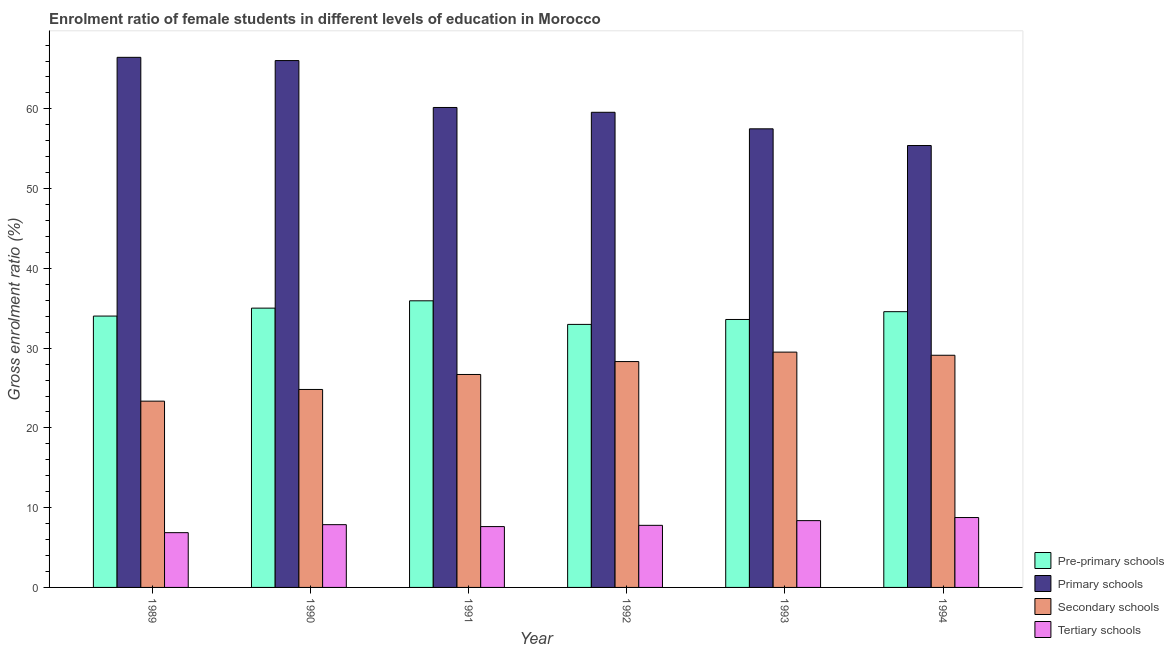How many groups of bars are there?
Keep it short and to the point. 6. In how many cases, is the number of bars for a given year not equal to the number of legend labels?
Give a very brief answer. 0. What is the gross enrolment ratio(male) in pre-primary schools in 1991?
Make the answer very short. 35.94. Across all years, what is the maximum gross enrolment ratio(male) in tertiary schools?
Offer a terse response. 8.76. Across all years, what is the minimum gross enrolment ratio(male) in pre-primary schools?
Your response must be concise. 32.98. In which year was the gross enrolment ratio(male) in primary schools maximum?
Provide a short and direct response. 1989. What is the total gross enrolment ratio(male) in secondary schools in the graph?
Your answer should be compact. 161.81. What is the difference between the gross enrolment ratio(male) in primary schools in 1989 and that in 1993?
Keep it short and to the point. 8.96. What is the difference between the gross enrolment ratio(male) in primary schools in 1993 and the gross enrolment ratio(male) in pre-primary schools in 1991?
Your response must be concise. -2.68. What is the average gross enrolment ratio(male) in pre-primary schools per year?
Your response must be concise. 34.36. In how many years, is the gross enrolment ratio(male) in primary schools greater than 42 %?
Ensure brevity in your answer.  6. What is the ratio of the gross enrolment ratio(male) in primary schools in 1989 to that in 1990?
Your response must be concise. 1.01. Is the gross enrolment ratio(male) in secondary schools in 1991 less than that in 1994?
Make the answer very short. Yes. Is the difference between the gross enrolment ratio(male) in primary schools in 1991 and 1994 greater than the difference between the gross enrolment ratio(male) in pre-primary schools in 1991 and 1994?
Keep it short and to the point. No. What is the difference between the highest and the second highest gross enrolment ratio(male) in tertiary schools?
Your answer should be compact. 0.39. What is the difference between the highest and the lowest gross enrolment ratio(male) in tertiary schools?
Your answer should be very brief. 1.9. Is the sum of the gross enrolment ratio(male) in tertiary schools in 1992 and 1994 greater than the maximum gross enrolment ratio(male) in primary schools across all years?
Offer a very short reply. Yes. Is it the case that in every year, the sum of the gross enrolment ratio(male) in secondary schools and gross enrolment ratio(male) in tertiary schools is greater than the sum of gross enrolment ratio(male) in pre-primary schools and gross enrolment ratio(male) in primary schools?
Offer a terse response. No. What does the 4th bar from the left in 1993 represents?
Make the answer very short. Tertiary schools. What does the 3rd bar from the right in 1994 represents?
Offer a very short reply. Primary schools. How many bars are there?
Ensure brevity in your answer.  24. How many years are there in the graph?
Give a very brief answer. 6. What is the difference between two consecutive major ticks on the Y-axis?
Your answer should be very brief. 10. Are the values on the major ticks of Y-axis written in scientific E-notation?
Ensure brevity in your answer.  No. How many legend labels are there?
Provide a succinct answer. 4. What is the title of the graph?
Your answer should be compact. Enrolment ratio of female students in different levels of education in Morocco. What is the Gross enrolment ratio (%) in Pre-primary schools in 1989?
Offer a terse response. 34.02. What is the Gross enrolment ratio (%) of Primary schools in 1989?
Keep it short and to the point. 66.47. What is the Gross enrolment ratio (%) in Secondary schools in 1989?
Make the answer very short. 23.36. What is the Gross enrolment ratio (%) of Tertiary schools in 1989?
Your response must be concise. 6.87. What is the Gross enrolment ratio (%) of Pre-primary schools in 1990?
Offer a terse response. 35.02. What is the Gross enrolment ratio (%) in Primary schools in 1990?
Ensure brevity in your answer.  66.06. What is the Gross enrolment ratio (%) of Secondary schools in 1990?
Ensure brevity in your answer.  24.82. What is the Gross enrolment ratio (%) in Tertiary schools in 1990?
Offer a terse response. 7.87. What is the Gross enrolment ratio (%) in Pre-primary schools in 1991?
Keep it short and to the point. 35.94. What is the Gross enrolment ratio (%) of Primary schools in 1991?
Ensure brevity in your answer.  60.18. What is the Gross enrolment ratio (%) of Secondary schools in 1991?
Your answer should be compact. 26.7. What is the Gross enrolment ratio (%) in Tertiary schools in 1991?
Make the answer very short. 7.63. What is the Gross enrolment ratio (%) of Pre-primary schools in 1992?
Provide a succinct answer. 32.98. What is the Gross enrolment ratio (%) of Primary schools in 1992?
Keep it short and to the point. 59.57. What is the Gross enrolment ratio (%) in Secondary schools in 1992?
Provide a short and direct response. 28.32. What is the Gross enrolment ratio (%) of Tertiary schools in 1992?
Your response must be concise. 7.79. What is the Gross enrolment ratio (%) of Pre-primary schools in 1993?
Give a very brief answer. 33.6. What is the Gross enrolment ratio (%) in Primary schools in 1993?
Offer a terse response. 57.5. What is the Gross enrolment ratio (%) in Secondary schools in 1993?
Give a very brief answer. 29.5. What is the Gross enrolment ratio (%) in Tertiary schools in 1993?
Your answer should be very brief. 8.38. What is the Gross enrolment ratio (%) in Pre-primary schools in 1994?
Your answer should be very brief. 34.57. What is the Gross enrolment ratio (%) of Primary schools in 1994?
Provide a succinct answer. 55.41. What is the Gross enrolment ratio (%) of Secondary schools in 1994?
Offer a very short reply. 29.11. What is the Gross enrolment ratio (%) of Tertiary schools in 1994?
Your answer should be very brief. 8.76. Across all years, what is the maximum Gross enrolment ratio (%) in Pre-primary schools?
Offer a very short reply. 35.94. Across all years, what is the maximum Gross enrolment ratio (%) in Primary schools?
Ensure brevity in your answer.  66.47. Across all years, what is the maximum Gross enrolment ratio (%) of Secondary schools?
Your answer should be very brief. 29.5. Across all years, what is the maximum Gross enrolment ratio (%) of Tertiary schools?
Provide a short and direct response. 8.76. Across all years, what is the minimum Gross enrolment ratio (%) of Pre-primary schools?
Make the answer very short. 32.98. Across all years, what is the minimum Gross enrolment ratio (%) of Primary schools?
Offer a terse response. 55.41. Across all years, what is the minimum Gross enrolment ratio (%) of Secondary schools?
Offer a very short reply. 23.36. Across all years, what is the minimum Gross enrolment ratio (%) of Tertiary schools?
Keep it short and to the point. 6.87. What is the total Gross enrolment ratio (%) in Pre-primary schools in the graph?
Provide a succinct answer. 206.13. What is the total Gross enrolment ratio (%) of Primary schools in the graph?
Offer a terse response. 365.18. What is the total Gross enrolment ratio (%) of Secondary schools in the graph?
Offer a very short reply. 161.81. What is the total Gross enrolment ratio (%) in Tertiary schools in the graph?
Give a very brief answer. 47.29. What is the difference between the Gross enrolment ratio (%) of Pre-primary schools in 1989 and that in 1990?
Provide a succinct answer. -1. What is the difference between the Gross enrolment ratio (%) in Primary schools in 1989 and that in 1990?
Keep it short and to the point. 0.41. What is the difference between the Gross enrolment ratio (%) of Secondary schools in 1989 and that in 1990?
Offer a very short reply. -1.46. What is the difference between the Gross enrolment ratio (%) in Tertiary schools in 1989 and that in 1990?
Provide a short and direct response. -1. What is the difference between the Gross enrolment ratio (%) in Pre-primary schools in 1989 and that in 1991?
Offer a terse response. -1.92. What is the difference between the Gross enrolment ratio (%) of Primary schools in 1989 and that in 1991?
Provide a short and direct response. 6.29. What is the difference between the Gross enrolment ratio (%) of Secondary schools in 1989 and that in 1991?
Your response must be concise. -3.34. What is the difference between the Gross enrolment ratio (%) in Tertiary schools in 1989 and that in 1991?
Your answer should be compact. -0.76. What is the difference between the Gross enrolment ratio (%) in Pre-primary schools in 1989 and that in 1992?
Keep it short and to the point. 1.04. What is the difference between the Gross enrolment ratio (%) of Primary schools in 1989 and that in 1992?
Your answer should be very brief. 6.89. What is the difference between the Gross enrolment ratio (%) in Secondary schools in 1989 and that in 1992?
Provide a succinct answer. -4.96. What is the difference between the Gross enrolment ratio (%) of Tertiary schools in 1989 and that in 1992?
Your response must be concise. -0.92. What is the difference between the Gross enrolment ratio (%) in Pre-primary schools in 1989 and that in 1993?
Make the answer very short. 0.43. What is the difference between the Gross enrolment ratio (%) of Primary schools in 1989 and that in 1993?
Your response must be concise. 8.96. What is the difference between the Gross enrolment ratio (%) in Secondary schools in 1989 and that in 1993?
Keep it short and to the point. -6.15. What is the difference between the Gross enrolment ratio (%) in Tertiary schools in 1989 and that in 1993?
Your answer should be compact. -1.51. What is the difference between the Gross enrolment ratio (%) of Pre-primary schools in 1989 and that in 1994?
Offer a terse response. -0.55. What is the difference between the Gross enrolment ratio (%) in Primary schools in 1989 and that in 1994?
Make the answer very short. 11.06. What is the difference between the Gross enrolment ratio (%) in Secondary schools in 1989 and that in 1994?
Offer a very short reply. -5.75. What is the difference between the Gross enrolment ratio (%) in Tertiary schools in 1989 and that in 1994?
Offer a terse response. -1.9. What is the difference between the Gross enrolment ratio (%) in Pre-primary schools in 1990 and that in 1991?
Keep it short and to the point. -0.92. What is the difference between the Gross enrolment ratio (%) in Primary schools in 1990 and that in 1991?
Your answer should be very brief. 5.88. What is the difference between the Gross enrolment ratio (%) of Secondary schools in 1990 and that in 1991?
Make the answer very short. -1.88. What is the difference between the Gross enrolment ratio (%) of Tertiary schools in 1990 and that in 1991?
Your answer should be compact. 0.24. What is the difference between the Gross enrolment ratio (%) of Pre-primary schools in 1990 and that in 1992?
Your answer should be very brief. 2.04. What is the difference between the Gross enrolment ratio (%) in Primary schools in 1990 and that in 1992?
Your response must be concise. 6.49. What is the difference between the Gross enrolment ratio (%) of Secondary schools in 1990 and that in 1992?
Ensure brevity in your answer.  -3.5. What is the difference between the Gross enrolment ratio (%) in Tertiary schools in 1990 and that in 1992?
Your answer should be compact. 0.08. What is the difference between the Gross enrolment ratio (%) in Pre-primary schools in 1990 and that in 1993?
Your answer should be compact. 1.42. What is the difference between the Gross enrolment ratio (%) in Primary schools in 1990 and that in 1993?
Provide a short and direct response. 8.56. What is the difference between the Gross enrolment ratio (%) of Secondary schools in 1990 and that in 1993?
Your answer should be compact. -4.68. What is the difference between the Gross enrolment ratio (%) in Tertiary schools in 1990 and that in 1993?
Give a very brief answer. -0.51. What is the difference between the Gross enrolment ratio (%) in Pre-primary schools in 1990 and that in 1994?
Offer a very short reply. 0.44. What is the difference between the Gross enrolment ratio (%) in Primary schools in 1990 and that in 1994?
Your answer should be compact. 10.65. What is the difference between the Gross enrolment ratio (%) of Secondary schools in 1990 and that in 1994?
Provide a short and direct response. -4.29. What is the difference between the Gross enrolment ratio (%) of Tertiary schools in 1990 and that in 1994?
Provide a succinct answer. -0.89. What is the difference between the Gross enrolment ratio (%) in Pre-primary schools in 1991 and that in 1992?
Offer a very short reply. 2.96. What is the difference between the Gross enrolment ratio (%) in Primary schools in 1991 and that in 1992?
Make the answer very short. 0.6. What is the difference between the Gross enrolment ratio (%) in Secondary schools in 1991 and that in 1992?
Offer a terse response. -1.62. What is the difference between the Gross enrolment ratio (%) in Tertiary schools in 1991 and that in 1992?
Ensure brevity in your answer.  -0.16. What is the difference between the Gross enrolment ratio (%) of Pre-primary schools in 1991 and that in 1993?
Provide a short and direct response. 2.34. What is the difference between the Gross enrolment ratio (%) of Primary schools in 1991 and that in 1993?
Offer a very short reply. 2.68. What is the difference between the Gross enrolment ratio (%) in Secondary schools in 1991 and that in 1993?
Offer a terse response. -2.8. What is the difference between the Gross enrolment ratio (%) in Tertiary schools in 1991 and that in 1993?
Offer a very short reply. -0.75. What is the difference between the Gross enrolment ratio (%) in Pre-primary schools in 1991 and that in 1994?
Provide a succinct answer. 1.36. What is the difference between the Gross enrolment ratio (%) in Primary schools in 1991 and that in 1994?
Your response must be concise. 4.77. What is the difference between the Gross enrolment ratio (%) in Secondary schools in 1991 and that in 1994?
Offer a terse response. -2.41. What is the difference between the Gross enrolment ratio (%) of Tertiary schools in 1991 and that in 1994?
Your answer should be very brief. -1.13. What is the difference between the Gross enrolment ratio (%) in Pre-primary schools in 1992 and that in 1993?
Give a very brief answer. -0.62. What is the difference between the Gross enrolment ratio (%) in Primary schools in 1992 and that in 1993?
Provide a short and direct response. 2.07. What is the difference between the Gross enrolment ratio (%) of Secondary schools in 1992 and that in 1993?
Provide a succinct answer. -1.19. What is the difference between the Gross enrolment ratio (%) of Tertiary schools in 1992 and that in 1993?
Offer a terse response. -0.59. What is the difference between the Gross enrolment ratio (%) in Pre-primary schools in 1992 and that in 1994?
Ensure brevity in your answer.  -1.59. What is the difference between the Gross enrolment ratio (%) in Primary schools in 1992 and that in 1994?
Your answer should be compact. 4.17. What is the difference between the Gross enrolment ratio (%) in Secondary schools in 1992 and that in 1994?
Make the answer very short. -0.79. What is the difference between the Gross enrolment ratio (%) of Tertiary schools in 1992 and that in 1994?
Your answer should be compact. -0.98. What is the difference between the Gross enrolment ratio (%) in Pre-primary schools in 1993 and that in 1994?
Keep it short and to the point. -0.98. What is the difference between the Gross enrolment ratio (%) in Primary schools in 1993 and that in 1994?
Provide a short and direct response. 2.09. What is the difference between the Gross enrolment ratio (%) of Secondary schools in 1993 and that in 1994?
Provide a succinct answer. 0.4. What is the difference between the Gross enrolment ratio (%) of Tertiary schools in 1993 and that in 1994?
Your response must be concise. -0.39. What is the difference between the Gross enrolment ratio (%) of Pre-primary schools in 1989 and the Gross enrolment ratio (%) of Primary schools in 1990?
Provide a succinct answer. -32.04. What is the difference between the Gross enrolment ratio (%) in Pre-primary schools in 1989 and the Gross enrolment ratio (%) in Secondary schools in 1990?
Keep it short and to the point. 9.2. What is the difference between the Gross enrolment ratio (%) in Pre-primary schools in 1989 and the Gross enrolment ratio (%) in Tertiary schools in 1990?
Your answer should be very brief. 26.15. What is the difference between the Gross enrolment ratio (%) of Primary schools in 1989 and the Gross enrolment ratio (%) of Secondary schools in 1990?
Provide a succinct answer. 41.64. What is the difference between the Gross enrolment ratio (%) of Primary schools in 1989 and the Gross enrolment ratio (%) of Tertiary schools in 1990?
Ensure brevity in your answer.  58.6. What is the difference between the Gross enrolment ratio (%) in Secondary schools in 1989 and the Gross enrolment ratio (%) in Tertiary schools in 1990?
Offer a terse response. 15.49. What is the difference between the Gross enrolment ratio (%) in Pre-primary schools in 1989 and the Gross enrolment ratio (%) in Primary schools in 1991?
Keep it short and to the point. -26.15. What is the difference between the Gross enrolment ratio (%) of Pre-primary schools in 1989 and the Gross enrolment ratio (%) of Secondary schools in 1991?
Your answer should be compact. 7.32. What is the difference between the Gross enrolment ratio (%) in Pre-primary schools in 1989 and the Gross enrolment ratio (%) in Tertiary schools in 1991?
Your answer should be compact. 26.39. What is the difference between the Gross enrolment ratio (%) of Primary schools in 1989 and the Gross enrolment ratio (%) of Secondary schools in 1991?
Keep it short and to the point. 39.77. What is the difference between the Gross enrolment ratio (%) in Primary schools in 1989 and the Gross enrolment ratio (%) in Tertiary schools in 1991?
Provide a short and direct response. 58.84. What is the difference between the Gross enrolment ratio (%) in Secondary schools in 1989 and the Gross enrolment ratio (%) in Tertiary schools in 1991?
Give a very brief answer. 15.73. What is the difference between the Gross enrolment ratio (%) in Pre-primary schools in 1989 and the Gross enrolment ratio (%) in Primary schools in 1992?
Your answer should be very brief. -25.55. What is the difference between the Gross enrolment ratio (%) in Pre-primary schools in 1989 and the Gross enrolment ratio (%) in Secondary schools in 1992?
Offer a very short reply. 5.7. What is the difference between the Gross enrolment ratio (%) of Pre-primary schools in 1989 and the Gross enrolment ratio (%) of Tertiary schools in 1992?
Give a very brief answer. 26.24. What is the difference between the Gross enrolment ratio (%) of Primary schools in 1989 and the Gross enrolment ratio (%) of Secondary schools in 1992?
Your answer should be compact. 38.15. What is the difference between the Gross enrolment ratio (%) of Primary schools in 1989 and the Gross enrolment ratio (%) of Tertiary schools in 1992?
Your answer should be very brief. 58.68. What is the difference between the Gross enrolment ratio (%) of Secondary schools in 1989 and the Gross enrolment ratio (%) of Tertiary schools in 1992?
Make the answer very short. 15.57. What is the difference between the Gross enrolment ratio (%) in Pre-primary schools in 1989 and the Gross enrolment ratio (%) in Primary schools in 1993?
Your answer should be very brief. -23.48. What is the difference between the Gross enrolment ratio (%) of Pre-primary schools in 1989 and the Gross enrolment ratio (%) of Secondary schools in 1993?
Your answer should be very brief. 4.52. What is the difference between the Gross enrolment ratio (%) in Pre-primary schools in 1989 and the Gross enrolment ratio (%) in Tertiary schools in 1993?
Your response must be concise. 25.65. What is the difference between the Gross enrolment ratio (%) of Primary schools in 1989 and the Gross enrolment ratio (%) of Secondary schools in 1993?
Make the answer very short. 36.96. What is the difference between the Gross enrolment ratio (%) in Primary schools in 1989 and the Gross enrolment ratio (%) in Tertiary schools in 1993?
Give a very brief answer. 58.09. What is the difference between the Gross enrolment ratio (%) of Secondary schools in 1989 and the Gross enrolment ratio (%) of Tertiary schools in 1993?
Offer a terse response. 14.98. What is the difference between the Gross enrolment ratio (%) of Pre-primary schools in 1989 and the Gross enrolment ratio (%) of Primary schools in 1994?
Provide a short and direct response. -21.38. What is the difference between the Gross enrolment ratio (%) in Pre-primary schools in 1989 and the Gross enrolment ratio (%) in Secondary schools in 1994?
Give a very brief answer. 4.91. What is the difference between the Gross enrolment ratio (%) in Pre-primary schools in 1989 and the Gross enrolment ratio (%) in Tertiary schools in 1994?
Your response must be concise. 25.26. What is the difference between the Gross enrolment ratio (%) of Primary schools in 1989 and the Gross enrolment ratio (%) of Secondary schools in 1994?
Give a very brief answer. 37.36. What is the difference between the Gross enrolment ratio (%) in Primary schools in 1989 and the Gross enrolment ratio (%) in Tertiary schools in 1994?
Your response must be concise. 57.7. What is the difference between the Gross enrolment ratio (%) in Secondary schools in 1989 and the Gross enrolment ratio (%) in Tertiary schools in 1994?
Keep it short and to the point. 14.59. What is the difference between the Gross enrolment ratio (%) of Pre-primary schools in 1990 and the Gross enrolment ratio (%) of Primary schools in 1991?
Make the answer very short. -25.16. What is the difference between the Gross enrolment ratio (%) of Pre-primary schools in 1990 and the Gross enrolment ratio (%) of Secondary schools in 1991?
Offer a very short reply. 8.32. What is the difference between the Gross enrolment ratio (%) in Pre-primary schools in 1990 and the Gross enrolment ratio (%) in Tertiary schools in 1991?
Your answer should be compact. 27.39. What is the difference between the Gross enrolment ratio (%) of Primary schools in 1990 and the Gross enrolment ratio (%) of Secondary schools in 1991?
Your answer should be compact. 39.36. What is the difference between the Gross enrolment ratio (%) of Primary schools in 1990 and the Gross enrolment ratio (%) of Tertiary schools in 1991?
Provide a short and direct response. 58.43. What is the difference between the Gross enrolment ratio (%) of Secondary schools in 1990 and the Gross enrolment ratio (%) of Tertiary schools in 1991?
Offer a terse response. 17.19. What is the difference between the Gross enrolment ratio (%) of Pre-primary schools in 1990 and the Gross enrolment ratio (%) of Primary schools in 1992?
Your answer should be very brief. -24.55. What is the difference between the Gross enrolment ratio (%) of Pre-primary schools in 1990 and the Gross enrolment ratio (%) of Secondary schools in 1992?
Offer a very short reply. 6.7. What is the difference between the Gross enrolment ratio (%) in Pre-primary schools in 1990 and the Gross enrolment ratio (%) in Tertiary schools in 1992?
Provide a short and direct response. 27.23. What is the difference between the Gross enrolment ratio (%) in Primary schools in 1990 and the Gross enrolment ratio (%) in Secondary schools in 1992?
Offer a terse response. 37.74. What is the difference between the Gross enrolment ratio (%) of Primary schools in 1990 and the Gross enrolment ratio (%) of Tertiary schools in 1992?
Keep it short and to the point. 58.27. What is the difference between the Gross enrolment ratio (%) of Secondary schools in 1990 and the Gross enrolment ratio (%) of Tertiary schools in 1992?
Your answer should be very brief. 17.03. What is the difference between the Gross enrolment ratio (%) in Pre-primary schools in 1990 and the Gross enrolment ratio (%) in Primary schools in 1993?
Your answer should be very brief. -22.48. What is the difference between the Gross enrolment ratio (%) of Pre-primary schools in 1990 and the Gross enrolment ratio (%) of Secondary schools in 1993?
Provide a succinct answer. 5.51. What is the difference between the Gross enrolment ratio (%) in Pre-primary schools in 1990 and the Gross enrolment ratio (%) in Tertiary schools in 1993?
Your answer should be very brief. 26.64. What is the difference between the Gross enrolment ratio (%) of Primary schools in 1990 and the Gross enrolment ratio (%) of Secondary schools in 1993?
Provide a succinct answer. 36.55. What is the difference between the Gross enrolment ratio (%) in Primary schools in 1990 and the Gross enrolment ratio (%) in Tertiary schools in 1993?
Your response must be concise. 57.68. What is the difference between the Gross enrolment ratio (%) of Secondary schools in 1990 and the Gross enrolment ratio (%) of Tertiary schools in 1993?
Give a very brief answer. 16.45. What is the difference between the Gross enrolment ratio (%) of Pre-primary schools in 1990 and the Gross enrolment ratio (%) of Primary schools in 1994?
Keep it short and to the point. -20.39. What is the difference between the Gross enrolment ratio (%) in Pre-primary schools in 1990 and the Gross enrolment ratio (%) in Secondary schools in 1994?
Your answer should be very brief. 5.91. What is the difference between the Gross enrolment ratio (%) of Pre-primary schools in 1990 and the Gross enrolment ratio (%) of Tertiary schools in 1994?
Offer a very short reply. 26.26. What is the difference between the Gross enrolment ratio (%) in Primary schools in 1990 and the Gross enrolment ratio (%) in Secondary schools in 1994?
Your answer should be very brief. 36.95. What is the difference between the Gross enrolment ratio (%) of Primary schools in 1990 and the Gross enrolment ratio (%) of Tertiary schools in 1994?
Make the answer very short. 57.3. What is the difference between the Gross enrolment ratio (%) in Secondary schools in 1990 and the Gross enrolment ratio (%) in Tertiary schools in 1994?
Give a very brief answer. 16.06. What is the difference between the Gross enrolment ratio (%) in Pre-primary schools in 1991 and the Gross enrolment ratio (%) in Primary schools in 1992?
Provide a succinct answer. -23.64. What is the difference between the Gross enrolment ratio (%) of Pre-primary schools in 1991 and the Gross enrolment ratio (%) of Secondary schools in 1992?
Your response must be concise. 7.62. What is the difference between the Gross enrolment ratio (%) of Pre-primary schools in 1991 and the Gross enrolment ratio (%) of Tertiary schools in 1992?
Keep it short and to the point. 28.15. What is the difference between the Gross enrolment ratio (%) of Primary schools in 1991 and the Gross enrolment ratio (%) of Secondary schools in 1992?
Keep it short and to the point. 31.86. What is the difference between the Gross enrolment ratio (%) of Primary schools in 1991 and the Gross enrolment ratio (%) of Tertiary schools in 1992?
Your answer should be compact. 52.39. What is the difference between the Gross enrolment ratio (%) of Secondary schools in 1991 and the Gross enrolment ratio (%) of Tertiary schools in 1992?
Your answer should be compact. 18.91. What is the difference between the Gross enrolment ratio (%) of Pre-primary schools in 1991 and the Gross enrolment ratio (%) of Primary schools in 1993?
Give a very brief answer. -21.56. What is the difference between the Gross enrolment ratio (%) in Pre-primary schools in 1991 and the Gross enrolment ratio (%) in Secondary schools in 1993?
Your answer should be very brief. 6.43. What is the difference between the Gross enrolment ratio (%) of Pre-primary schools in 1991 and the Gross enrolment ratio (%) of Tertiary schools in 1993?
Provide a short and direct response. 27.56. What is the difference between the Gross enrolment ratio (%) of Primary schools in 1991 and the Gross enrolment ratio (%) of Secondary schools in 1993?
Give a very brief answer. 30.67. What is the difference between the Gross enrolment ratio (%) in Primary schools in 1991 and the Gross enrolment ratio (%) in Tertiary schools in 1993?
Ensure brevity in your answer.  51.8. What is the difference between the Gross enrolment ratio (%) of Secondary schools in 1991 and the Gross enrolment ratio (%) of Tertiary schools in 1993?
Offer a very short reply. 18.32. What is the difference between the Gross enrolment ratio (%) of Pre-primary schools in 1991 and the Gross enrolment ratio (%) of Primary schools in 1994?
Give a very brief answer. -19.47. What is the difference between the Gross enrolment ratio (%) in Pre-primary schools in 1991 and the Gross enrolment ratio (%) in Secondary schools in 1994?
Keep it short and to the point. 6.83. What is the difference between the Gross enrolment ratio (%) of Pre-primary schools in 1991 and the Gross enrolment ratio (%) of Tertiary schools in 1994?
Your response must be concise. 27.18. What is the difference between the Gross enrolment ratio (%) in Primary schools in 1991 and the Gross enrolment ratio (%) in Secondary schools in 1994?
Your answer should be compact. 31.07. What is the difference between the Gross enrolment ratio (%) in Primary schools in 1991 and the Gross enrolment ratio (%) in Tertiary schools in 1994?
Make the answer very short. 51.41. What is the difference between the Gross enrolment ratio (%) of Secondary schools in 1991 and the Gross enrolment ratio (%) of Tertiary schools in 1994?
Provide a short and direct response. 17.94. What is the difference between the Gross enrolment ratio (%) of Pre-primary schools in 1992 and the Gross enrolment ratio (%) of Primary schools in 1993?
Offer a terse response. -24.52. What is the difference between the Gross enrolment ratio (%) of Pre-primary schools in 1992 and the Gross enrolment ratio (%) of Secondary schools in 1993?
Provide a succinct answer. 3.48. What is the difference between the Gross enrolment ratio (%) of Pre-primary schools in 1992 and the Gross enrolment ratio (%) of Tertiary schools in 1993?
Make the answer very short. 24.61. What is the difference between the Gross enrolment ratio (%) of Primary schools in 1992 and the Gross enrolment ratio (%) of Secondary schools in 1993?
Offer a very short reply. 30.07. What is the difference between the Gross enrolment ratio (%) of Primary schools in 1992 and the Gross enrolment ratio (%) of Tertiary schools in 1993?
Make the answer very short. 51.2. What is the difference between the Gross enrolment ratio (%) in Secondary schools in 1992 and the Gross enrolment ratio (%) in Tertiary schools in 1993?
Ensure brevity in your answer.  19.94. What is the difference between the Gross enrolment ratio (%) in Pre-primary schools in 1992 and the Gross enrolment ratio (%) in Primary schools in 1994?
Give a very brief answer. -22.43. What is the difference between the Gross enrolment ratio (%) of Pre-primary schools in 1992 and the Gross enrolment ratio (%) of Secondary schools in 1994?
Ensure brevity in your answer.  3.87. What is the difference between the Gross enrolment ratio (%) of Pre-primary schools in 1992 and the Gross enrolment ratio (%) of Tertiary schools in 1994?
Your response must be concise. 24.22. What is the difference between the Gross enrolment ratio (%) in Primary schools in 1992 and the Gross enrolment ratio (%) in Secondary schools in 1994?
Ensure brevity in your answer.  30.46. What is the difference between the Gross enrolment ratio (%) in Primary schools in 1992 and the Gross enrolment ratio (%) in Tertiary schools in 1994?
Offer a terse response. 50.81. What is the difference between the Gross enrolment ratio (%) of Secondary schools in 1992 and the Gross enrolment ratio (%) of Tertiary schools in 1994?
Provide a short and direct response. 19.56. What is the difference between the Gross enrolment ratio (%) in Pre-primary schools in 1993 and the Gross enrolment ratio (%) in Primary schools in 1994?
Provide a short and direct response. -21.81. What is the difference between the Gross enrolment ratio (%) in Pre-primary schools in 1993 and the Gross enrolment ratio (%) in Secondary schools in 1994?
Keep it short and to the point. 4.49. What is the difference between the Gross enrolment ratio (%) of Pre-primary schools in 1993 and the Gross enrolment ratio (%) of Tertiary schools in 1994?
Provide a short and direct response. 24.83. What is the difference between the Gross enrolment ratio (%) of Primary schools in 1993 and the Gross enrolment ratio (%) of Secondary schools in 1994?
Provide a succinct answer. 28.39. What is the difference between the Gross enrolment ratio (%) of Primary schools in 1993 and the Gross enrolment ratio (%) of Tertiary schools in 1994?
Offer a terse response. 48.74. What is the difference between the Gross enrolment ratio (%) of Secondary schools in 1993 and the Gross enrolment ratio (%) of Tertiary schools in 1994?
Offer a very short reply. 20.74. What is the average Gross enrolment ratio (%) in Pre-primary schools per year?
Offer a terse response. 34.36. What is the average Gross enrolment ratio (%) of Primary schools per year?
Keep it short and to the point. 60.86. What is the average Gross enrolment ratio (%) in Secondary schools per year?
Provide a short and direct response. 26.97. What is the average Gross enrolment ratio (%) in Tertiary schools per year?
Offer a terse response. 7.88. In the year 1989, what is the difference between the Gross enrolment ratio (%) of Pre-primary schools and Gross enrolment ratio (%) of Primary schools?
Offer a terse response. -32.44. In the year 1989, what is the difference between the Gross enrolment ratio (%) of Pre-primary schools and Gross enrolment ratio (%) of Secondary schools?
Your answer should be very brief. 10.67. In the year 1989, what is the difference between the Gross enrolment ratio (%) in Pre-primary schools and Gross enrolment ratio (%) in Tertiary schools?
Make the answer very short. 27.16. In the year 1989, what is the difference between the Gross enrolment ratio (%) of Primary schools and Gross enrolment ratio (%) of Secondary schools?
Provide a short and direct response. 43.11. In the year 1989, what is the difference between the Gross enrolment ratio (%) of Primary schools and Gross enrolment ratio (%) of Tertiary schools?
Your answer should be very brief. 59.6. In the year 1989, what is the difference between the Gross enrolment ratio (%) in Secondary schools and Gross enrolment ratio (%) in Tertiary schools?
Offer a very short reply. 16.49. In the year 1990, what is the difference between the Gross enrolment ratio (%) of Pre-primary schools and Gross enrolment ratio (%) of Primary schools?
Give a very brief answer. -31.04. In the year 1990, what is the difference between the Gross enrolment ratio (%) of Pre-primary schools and Gross enrolment ratio (%) of Secondary schools?
Provide a short and direct response. 10.2. In the year 1990, what is the difference between the Gross enrolment ratio (%) of Pre-primary schools and Gross enrolment ratio (%) of Tertiary schools?
Keep it short and to the point. 27.15. In the year 1990, what is the difference between the Gross enrolment ratio (%) of Primary schools and Gross enrolment ratio (%) of Secondary schools?
Your response must be concise. 41.24. In the year 1990, what is the difference between the Gross enrolment ratio (%) in Primary schools and Gross enrolment ratio (%) in Tertiary schools?
Your answer should be very brief. 58.19. In the year 1990, what is the difference between the Gross enrolment ratio (%) of Secondary schools and Gross enrolment ratio (%) of Tertiary schools?
Provide a succinct answer. 16.95. In the year 1991, what is the difference between the Gross enrolment ratio (%) in Pre-primary schools and Gross enrolment ratio (%) in Primary schools?
Make the answer very short. -24.24. In the year 1991, what is the difference between the Gross enrolment ratio (%) of Pre-primary schools and Gross enrolment ratio (%) of Secondary schools?
Your answer should be very brief. 9.24. In the year 1991, what is the difference between the Gross enrolment ratio (%) of Pre-primary schools and Gross enrolment ratio (%) of Tertiary schools?
Offer a terse response. 28.31. In the year 1991, what is the difference between the Gross enrolment ratio (%) in Primary schools and Gross enrolment ratio (%) in Secondary schools?
Offer a terse response. 33.48. In the year 1991, what is the difference between the Gross enrolment ratio (%) of Primary schools and Gross enrolment ratio (%) of Tertiary schools?
Offer a terse response. 52.55. In the year 1991, what is the difference between the Gross enrolment ratio (%) in Secondary schools and Gross enrolment ratio (%) in Tertiary schools?
Your answer should be very brief. 19.07. In the year 1992, what is the difference between the Gross enrolment ratio (%) of Pre-primary schools and Gross enrolment ratio (%) of Primary schools?
Offer a very short reply. -26.59. In the year 1992, what is the difference between the Gross enrolment ratio (%) of Pre-primary schools and Gross enrolment ratio (%) of Secondary schools?
Your answer should be very brief. 4.66. In the year 1992, what is the difference between the Gross enrolment ratio (%) of Pre-primary schools and Gross enrolment ratio (%) of Tertiary schools?
Your answer should be very brief. 25.19. In the year 1992, what is the difference between the Gross enrolment ratio (%) of Primary schools and Gross enrolment ratio (%) of Secondary schools?
Provide a succinct answer. 31.26. In the year 1992, what is the difference between the Gross enrolment ratio (%) of Primary schools and Gross enrolment ratio (%) of Tertiary schools?
Offer a very short reply. 51.79. In the year 1992, what is the difference between the Gross enrolment ratio (%) in Secondary schools and Gross enrolment ratio (%) in Tertiary schools?
Offer a terse response. 20.53. In the year 1993, what is the difference between the Gross enrolment ratio (%) of Pre-primary schools and Gross enrolment ratio (%) of Primary schools?
Offer a terse response. -23.9. In the year 1993, what is the difference between the Gross enrolment ratio (%) in Pre-primary schools and Gross enrolment ratio (%) in Secondary schools?
Make the answer very short. 4.09. In the year 1993, what is the difference between the Gross enrolment ratio (%) of Pre-primary schools and Gross enrolment ratio (%) of Tertiary schools?
Keep it short and to the point. 25.22. In the year 1993, what is the difference between the Gross enrolment ratio (%) in Primary schools and Gross enrolment ratio (%) in Secondary schools?
Your response must be concise. 28. In the year 1993, what is the difference between the Gross enrolment ratio (%) of Primary schools and Gross enrolment ratio (%) of Tertiary schools?
Offer a very short reply. 49.13. In the year 1993, what is the difference between the Gross enrolment ratio (%) in Secondary schools and Gross enrolment ratio (%) in Tertiary schools?
Keep it short and to the point. 21.13. In the year 1994, what is the difference between the Gross enrolment ratio (%) of Pre-primary schools and Gross enrolment ratio (%) of Primary schools?
Make the answer very short. -20.83. In the year 1994, what is the difference between the Gross enrolment ratio (%) in Pre-primary schools and Gross enrolment ratio (%) in Secondary schools?
Your answer should be compact. 5.47. In the year 1994, what is the difference between the Gross enrolment ratio (%) of Pre-primary schools and Gross enrolment ratio (%) of Tertiary schools?
Offer a terse response. 25.81. In the year 1994, what is the difference between the Gross enrolment ratio (%) of Primary schools and Gross enrolment ratio (%) of Secondary schools?
Provide a short and direct response. 26.3. In the year 1994, what is the difference between the Gross enrolment ratio (%) of Primary schools and Gross enrolment ratio (%) of Tertiary schools?
Offer a very short reply. 46.64. In the year 1994, what is the difference between the Gross enrolment ratio (%) in Secondary schools and Gross enrolment ratio (%) in Tertiary schools?
Give a very brief answer. 20.35. What is the ratio of the Gross enrolment ratio (%) in Pre-primary schools in 1989 to that in 1990?
Offer a terse response. 0.97. What is the ratio of the Gross enrolment ratio (%) of Primary schools in 1989 to that in 1990?
Keep it short and to the point. 1.01. What is the ratio of the Gross enrolment ratio (%) in Secondary schools in 1989 to that in 1990?
Ensure brevity in your answer.  0.94. What is the ratio of the Gross enrolment ratio (%) of Tertiary schools in 1989 to that in 1990?
Provide a short and direct response. 0.87. What is the ratio of the Gross enrolment ratio (%) of Pre-primary schools in 1989 to that in 1991?
Provide a short and direct response. 0.95. What is the ratio of the Gross enrolment ratio (%) in Primary schools in 1989 to that in 1991?
Ensure brevity in your answer.  1.1. What is the ratio of the Gross enrolment ratio (%) in Secondary schools in 1989 to that in 1991?
Ensure brevity in your answer.  0.87. What is the ratio of the Gross enrolment ratio (%) in Tertiary schools in 1989 to that in 1991?
Keep it short and to the point. 0.9. What is the ratio of the Gross enrolment ratio (%) in Pre-primary schools in 1989 to that in 1992?
Provide a short and direct response. 1.03. What is the ratio of the Gross enrolment ratio (%) of Primary schools in 1989 to that in 1992?
Give a very brief answer. 1.12. What is the ratio of the Gross enrolment ratio (%) in Secondary schools in 1989 to that in 1992?
Your answer should be compact. 0.82. What is the ratio of the Gross enrolment ratio (%) of Tertiary schools in 1989 to that in 1992?
Provide a short and direct response. 0.88. What is the ratio of the Gross enrolment ratio (%) of Pre-primary schools in 1989 to that in 1993?
Keep it short and to the point. 1.01. What is the ratio of the Gross enrolment ratio (%) in Primary schools in 1989 to that in 1993?
Provide a succinct answer. 1.16. What is the ratio of the Gross enrolment ratio (%) of Secondary schools in 1989 to that in 1993?
Give a very brief answer. 0.79. What is the ratio of the Gross enrolment ratio (%) of Tertiary schools in 1989 to that in 1993?
Your answer should be very brief. 0.82. What is the ratio of the Gross enrolment ratio (%) in Pre-primary schools in 1989 to that in 1994?
Offer a very short reply. 0.98. What is the ratio of the Gross enrolment ratio (%) in Primary schools in 1989 to that in 1994?
Keep it short and to the point. 1.2. What is the ratio of the Gross enrolment ratio (%) of Secondary schools in 1989 to that in 1994?
Ensure brevity in your answer.  0.8. What is the ratio of the Gross enrolment ratio (%) of Tertiary schools in 1989 to that in 1994?
Your response must be concise. 0.78. What is the ratio of the Gross enrolment ratio (%) of Pre-primary schools in 1990 to that in 1991?
Keep it short and to the point. 0.97. What is the ratio of the Gross enrolment ratio (%) in Primary schools in 1990 to that in 1991?
Offer a very short reply. 1.1. What is the ratio of the Gross enrolment ratio (%) of Secondary schools in 1990 to that in 1991?
Keep it short and to the point. 0.93. What is the ratio of the Gross enrolment ratio (%) in Tertiary schools in 1990 to that in 1991?
Ensure brevity in your answer.  1.03. What is the ratio of the Gross enrolment ratio (%) of Pre-primary schools in 1990 to that in 1992?
Keep it short and to the point. 1.06. What is the ratio of the Gross enrolment ratio (%) of Primary schools in 1990 to that in 1992?
Ensure brevity in your answer.  1.11. What is the ratio of the Gross enrolment ratio (%) in Secondary schools in 1990 to that in 1992?
Provide a succinct answer. 0.88. What is the ratio of the Gross enrolment ratio (%) in Tertiary schools in 1990 to that in 1992?
Offer a terse response. 1.01. What is the ratio of the Gross enrolment ratio (%) of Pre-primary schools in 1990 to that in 1993?
Make the answer very short. 1.04. What is the ratio of the Gross enrolment ratio (%) of Primary schools in 1990 to that in 1993?
Provide a short and direct response. 1.15. What is the ratio of the Gross enrolment ratio (%) of Secondary schools in 1990 to that in 1993?
Keep it short and to the point. 0.84. What is the ratio of the Gross enrolment ratio (%) in Tertiary schools in 1990 to that in 1993?
Keep it short and to the point. 0.94. What is the ratio of the Gross enrolment ratio (%) of Pre-primary schools in 1990 to that in 1994?
Make the answer very short. 1.01. What is the ratio of the Gross enrolment ratio (%) in Primary schools in 1990 to that in 1994?
Make the answer very short. 1.19. What is the ratio of the Gross enrolment ratio (%) of Secondary schools in 1990 to that in 1994?
Offer a terse response. 0.85. What is the ratio of the Gross enrolment ratio (%) of Tertiary schools in 1990 to that in 1994?
Your answer should be very brief. 0.9. What is the ratio of the Gross enrolment ratio (%) of Pre-primary schools in 1991 to that in 1992?
Your answer should be very brief. 1.09. What is the ratio of the Gross enrolment ratio (%) in Primary schools in 1991 to that in 1992?
Give a very brief answer. 1.01. What is the ratio of the Gross enrolment ratio (%) in Secondary schools in 1991 to that in 1992?
Ensure brevity in your answer.  0.94. What is the ratio of the Gross enrolment ratio (%) in Tertiary schools in 1991 to that in 1992?
Your answer should be very brief. 0.98. What is the ratio of the Gross enrolment ratio (%) in Pre-primary schools in 1991 to that in 1993?
Your response must be concise. 1.07. What is the ratio of the Gross enrolment ratio (%) in Primary schools in 1991 to that in 1993?
Your answer should be compact. 1.05. What is the ratio of the Gross enrolment ratio (%) of Secondary schools in 1991 to that in 1993?
Your response must be concise. 0.9. What is the ratio of the Gross enrolment ratio (%) of Tertiary schools in 1991 to that in 1993?
Provide a succinct answer. 0.91. What is the ratio of the Gross enrolment ratio (%) of Pre-primary schools in 1991 to that in 1994?
Offer a terse response. 1.04. What is the ratio of the Gross enrolment ratio (%) in Primary schools in 1991 to that in 1994?
Your answer should be compact. 1.09. What is the ratio of the Gross enrolment ratio (%) of Secondary schools in 1991 to that in 1994?
Keep it short and to the point. 0.92. What is the ratio of the Gross enrolment ratio (%) of Tertiary schools in 1991 to that in 1994?
Provide a succinct answer. 0.87. What is the ratio of the Gross enrolment ratio (%) of Pre-primary schools in 1992 to that in 1993?
Keep it short and to the point. 0.98. What is the ratio of the Gross enrolment ratio (%) of Primary schools in 1992 to that in 1993?
Your answer should be very brief. 1.04. What is the ratio of the Gross enrolment ratio (%) of Secondary schools in 1992 to that in 1993?
Make the answer very short. 0.96. What is the ratio of the Gross enrolment ratio (%) of Tertiary schools in 1992 to that in 1993?
Your response must be concise. 0.93. What is the ratio of the Gross enrolment ratio (%) in Pre-primary schools in 1992 to that in 1994?
Keep it short and to the point. 0.95. What is the ratio of the Gross enrolment ratio (%) in Primary schools in 1992 to that in 1994?
Keep it short and to the point. 1.08. What is the ratio of the Gross enrolment ratio (%) of Secondary schools in 1992 to that in 1994?
Your answer should be very brief. 0.97. What is the ratio of the Gross enrolment ratio (%) in Tertiary schools in 1992 to that in 1994?
Provide a short and direct response. 0.89. What is the ratio of the Gross enrolment ratio (%) of Pre-primary schools in 1993 to that in 1994?
Offer a terse response. 0.97. What is the ratio of the Gross enrolment ratio (%) of Primary schools in 1993 to that in 1994?
Offer a terse response. 1.04. What is the ratio of the Gross enrolment ratio (%) of Secondary schools in 1993 to that in 1994?
Your answer should be compact. 1.01. What is the ratio of the Gross enrolment ratio (%) in Tertiary schools in 1993 to that in 1994?
Your answer should be compact. 0.96. What is the difference between the highest and the second highest Gross enrolment ratio (%) of Pre-primary schools?
Your response must be concise. 0.92. What is the difference between the highest and the second highest Gross enrolment ratio (%) of Primary schools?
Your response must be concise. 0.41. What is the difference between the highest and the second highest Gross enrolment ratio (%) in Secondary schools?
Your answer should be very brief. 0.4. What is the difference between the highest and the second highest Gross enrolment ratio (%) in Tertiary schools?
Give a very brief answer. 0.39. What is the difference between the highest and the lowest Gross enrolment ratio (%) in Pre-primary schools?
Give a very brief answer. 2.96. What is the difference between the highest and the lowest Gross enrolment ratio (%) of Primary schools?
Your answer should be very brief. 11.06. What is the difference between the highest and the lowest Gross enrolment ratio (%) in Secondary schools?
Keep it short and to the point. 6.15. What is the difference between the highest and the lowest Gross enrolment ratio (%) of Tertiary schools?
Give a very brief answer. 1.9. 